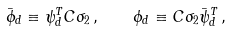Convert formula to latex. <formula><loc_0><loc_0><loc_500><loc_500>\bar { \phi } _ { d } \equiv \psi _ { d } ^ { T } C \sigma _ { 2 } \, , \quad \phi _ { d } \equiv C \sigma _ { 2 } \bar { \psi } _ { d } ^ { T } \, ,</formula> 